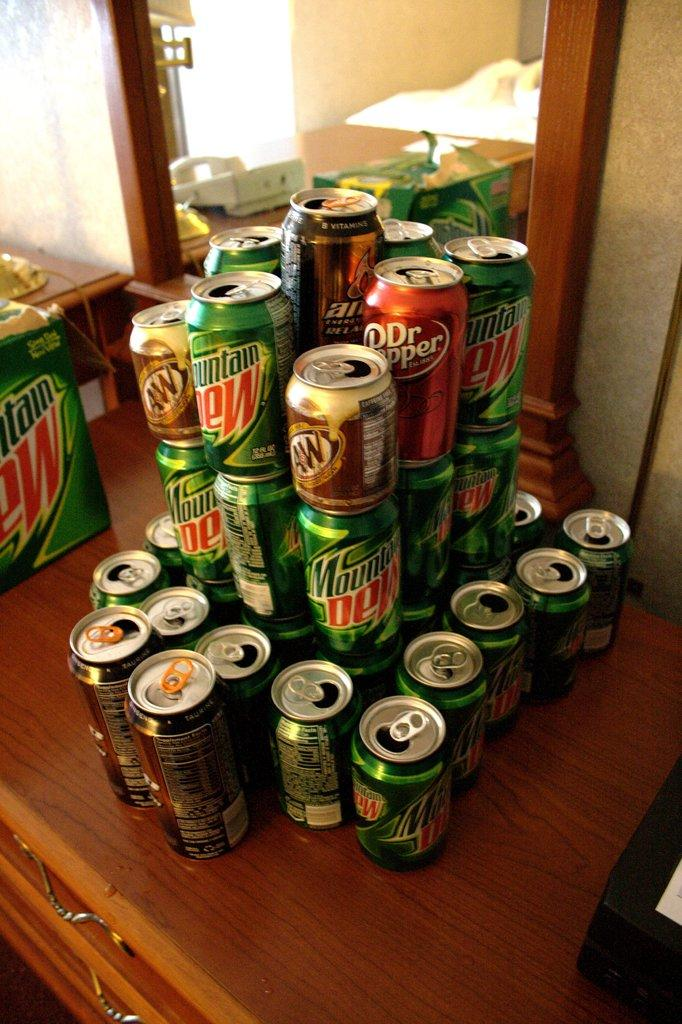<image>
Write a terse but informative summary of the picture. Empty soda cans, including Mountain Dew and Dr. Pepper, are stacked on a dresser. 